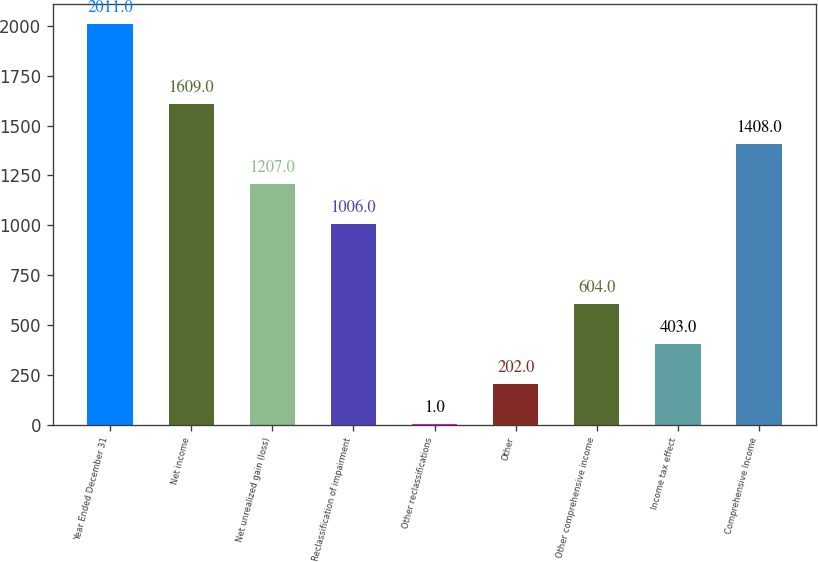Convert chart to OTSL. <chart><loc_0><loc_0><loc_500><loc_500><bar_chart><fcel>Year Ended December 31<fcel>Net income<fcel>Net unrealized gain (loss)<fcel>Reclassification of impairment<fcel>Other reclassifications<fcel>Other<fcel>Other comprehensive income<fcel>Income tax effect<fcel>Comprehensive Income<nl><fcel>2011<fcel>1609<fcel>1207<fcel>1006<fcel>1<fcel>202<fcel>604<fcel>403<fcel>1408<nl></chart> 